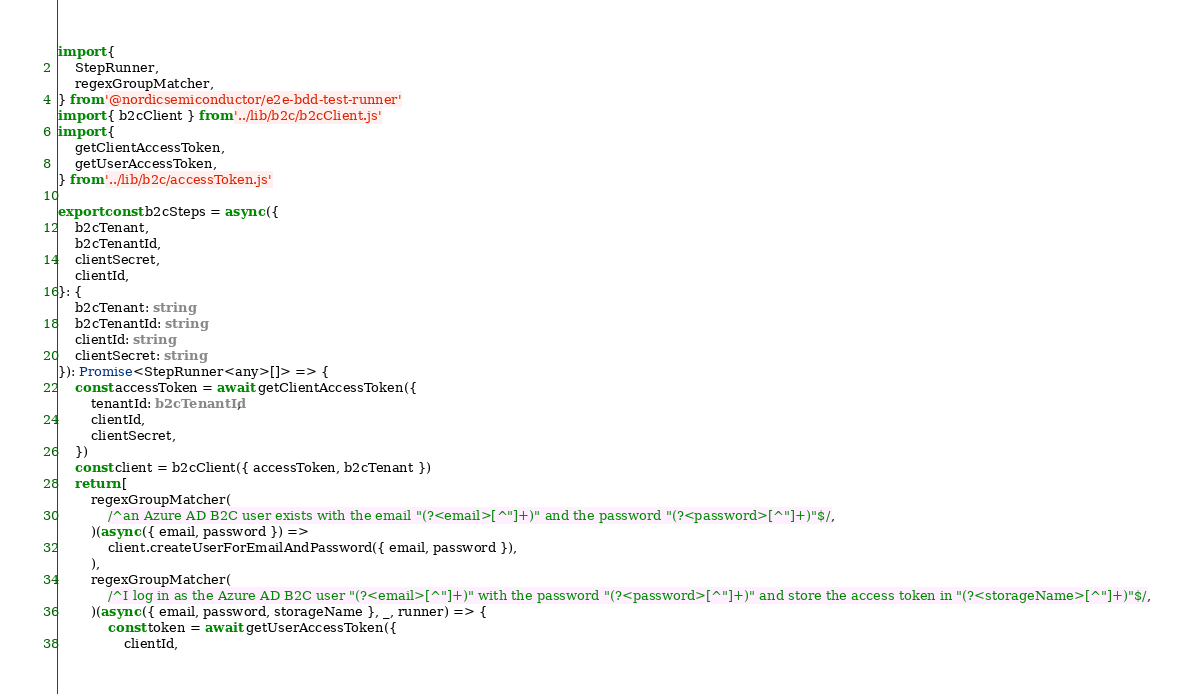Convert code to text. <code><loc_0><loc_0><loc_500><loc_500><_TypeScript_>import {
	StepRunner,
	regexGroupMatcher,
} from '@nordicsemiconductor/e2e-bdd-test-runner'
import { b2cClient } from '../lib/b2c/b2cClient.js'
import {
	getClientAccessToken,
	getUserAccessToken,
} from '../lib/b2c/accessToken.js'

export const b2cSteps = async ({
	b2cTenant,
	b2cTenantId,
	clientSecret,
	clientId,
}: {
	b2cTenant: string
	b2cTenantId: string
	clientId: string
	clientSecret: string
}): Promise<StepRunner<any>[]> => {
	const accessToken = await getClientAccessToken({
		tenantId: b2cTenantId,
		clientId,
		clientSecret,
	})
	const client = b2cClient({ accessToken, b2cTenant })
	return [
		regexGroupMatcher(
			/^an Azure AD B2C user exists with the email "(?<email>[^"]+)" and the password "(?<password>[^"]+)"$/,
		)(async ({ email, password }) =>
			client.createUserForEmailAndPassword({ email, password }),
		),
		regexGroupMatcher(
			/^I log in as the Azure AD B2C user "(?<email>[^"]+)" with the password "(?<password>[^"]+)" and store the access token in "(?<storageName>[^"]+)"$/,
		)(async ({ email, password, storageName }, _, runner) => {
			const token = await getUserAccessToken({
				clientId,</code> 